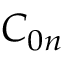Convert formula to latex. <formula><loc_0><loc_0><loc_500><loc_500>C _ { 0 n }</formula> 